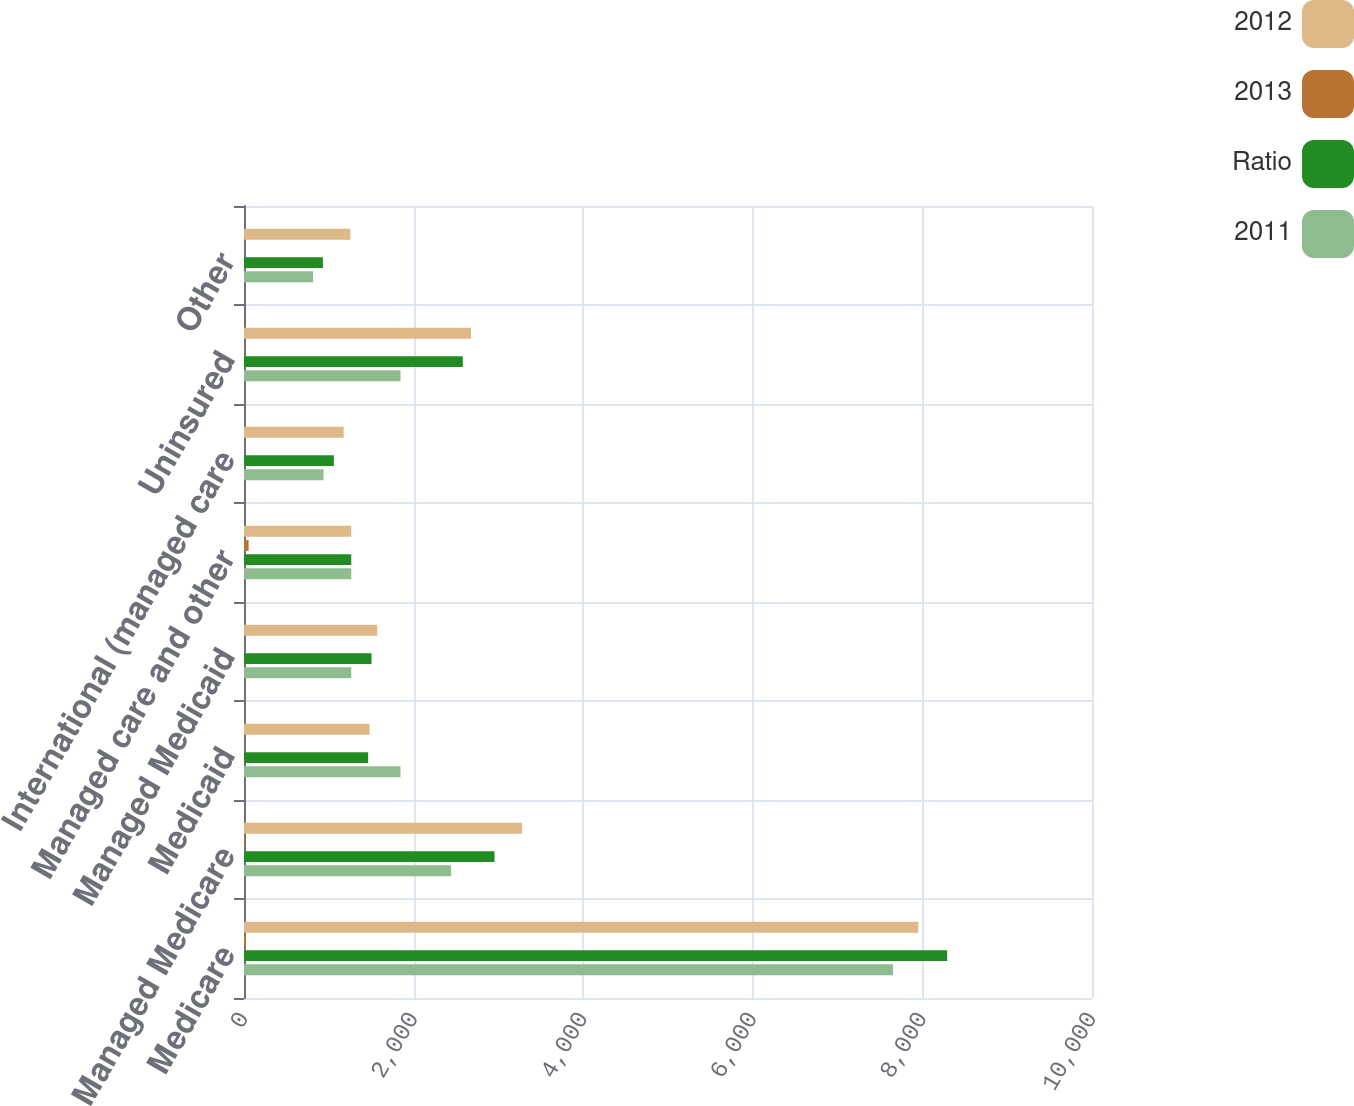<chart> <loc_0><loc_0><loc_500><loc_500><stacked_bar_chart><ecel><fcel>Medicare<fcel>Managed Medicare<fcel>Medicaid<fcel>Managed Medicaid<fcel>Managed care and other<fcel>International (managed care<fcel>Uninsured<fcel>Other<nl><fcel>2012<fcel>7951<fcel>3279<fcel>1480<fcel>1570<fcel>1265<fcel>1175<fcel>2677<fcel>1254<nl><fcel>2013<fcel>23.3<fcel>9.6<fcel>4.3<fcel>4.6<fcel>54.6<fcel>3.4<fcel>7.8<fcel>3.7<nl><fcel>Ratio<fcel>8292<fcel>2954<fcel>1464<fcel>1504<fcel>1265<fcel>1060<fcel>2580<fcel>931<nl><fcel>2011<fcel>7653<fcel>2442<fcel>1845<fcel>1265<fcel>1265<fcel>938<fcel>1846<fcel>814<nl></chart> 